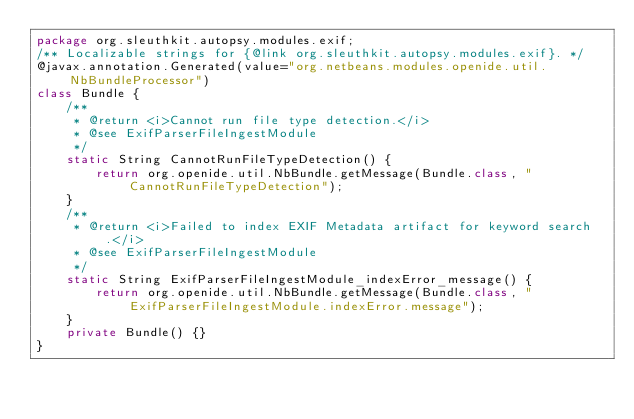<code> <loc_0><loc_0><loc_500><loc_500><_Java_>package org.sleuthkit.autopsy.modules.exif;
/** Localizable strings for {@link org.sleuthkit.autopsy.modules.exif}. */
@javax.annotation.Generated(value="org.netbeans.modules.openide.util.NbBundleProcessor")
class Bundle {
    /**
     * @return <i>Cannot run file type detection.</i>
     * @see ExifParserFileIngestModule
     */
    static String CannotRunFileTypeDetection() {
        return org.openide.util.NbBundle.getMessage(Bundle.class, "CannotRunFileTypeDetection");
    }
    /**
     * @return <i>Failed to index EXIF Metadata artifact for keyword search.</i>
     * @see ExifParserFileIngestModule
     */
    static String ExifParserFileIngestModule_indexError_message() {
        return org.openide.util.NbBundle.getMessage(Bundle.class, "ExifParserFileIngestModule.indexError.message");
    }
    private Bundle() {}
}
</code> 